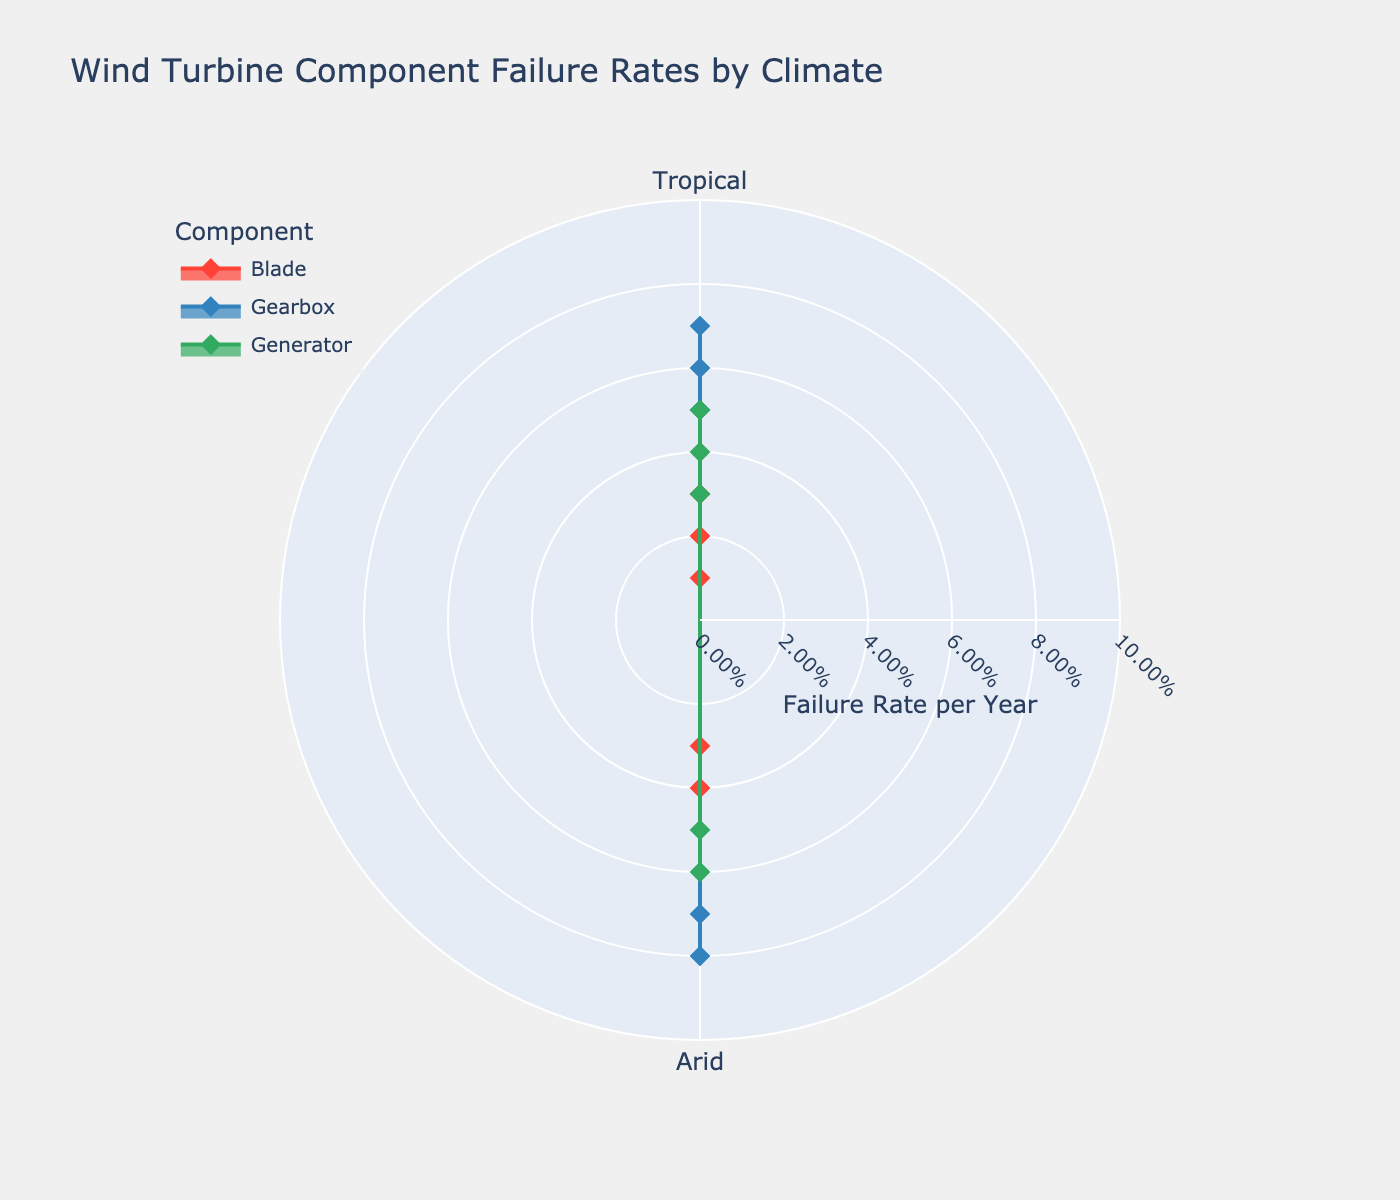What's the title of the chart? The title is located at the top of the chart and provides an overview of what the chart is about.
Answer: Wind Turbine Component Failure Rates by Climate What component has the highest failure rate in the Cold climate? Look at the radial distance from the center for each component in the Cold sector and identify the longest one.
Answer: Gearbox Which climate has the lowest failure rate for Blades? Compare the radial distances from the center for Blades in each climate sector and pick the smallest one.
Answer: Temperate In which climates does the Generator component have a failure rate higher than 0.05? Check the radial distances for the Generator in each sector, noting those greater than 0.05.
Answer: Tropical, Cold What is the difference in failure rates of the Gearbox component between Arid and Cold climates? Locate the failure rates for Gearbox in Arid and Cold climates, subtract the smaller value from the larger one.
Answer: 0.02 Which component generally has the lowest failure rates across all climates? Compare the radial distances of each component in all climate sectors and identify the one with the smallest distances overall.
Answer: Blade How many components have a failure rate of at least 0.06 in the Tropical climate? Identify the radial distances for each component in the Tropical sector that are 0.06 or higher and count them.
Answer: 1 Is there any component with a failure rate above 0.05 in the Temperate climate? Look at the radial distances for each component in the Temperate sector and see if any are above 0.05.
Answer: No What is the average failure rate of the Generator component across all climates? Add up the radial distances of the Generator component in each climate sector and divide by the number of climates.
Answer: 0.045 